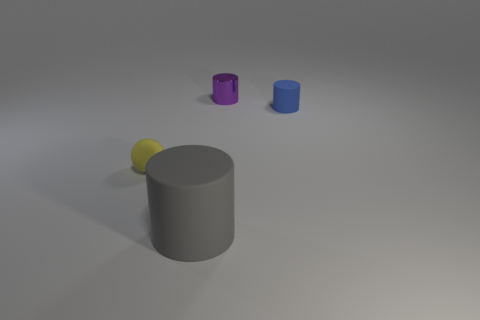Add 4 small objects. How many objects exist? 8 Subtract all rubber cylinders. How many cylinders are left? 1 Subtract all cylinders. How many objects are left? 1 Subtract 3 cylinders. How many cylinders are left? 0 Subtract 0 cyan cylinders. How many objects are left? 4 Subtract all brown cylinders. Subtract all red spheres. How many cylinders are left? 3 Subtract all tiny matte cylinders. Subtract all small brown objects. How many objects are left? 3 Add 1 big cylinders. How many big cylinders are left? 2 Add 2 blue matte cylinders. How many blue matte cylinders exist? 3 Subtract all gray cylinders. How many cylinders are left? 2 